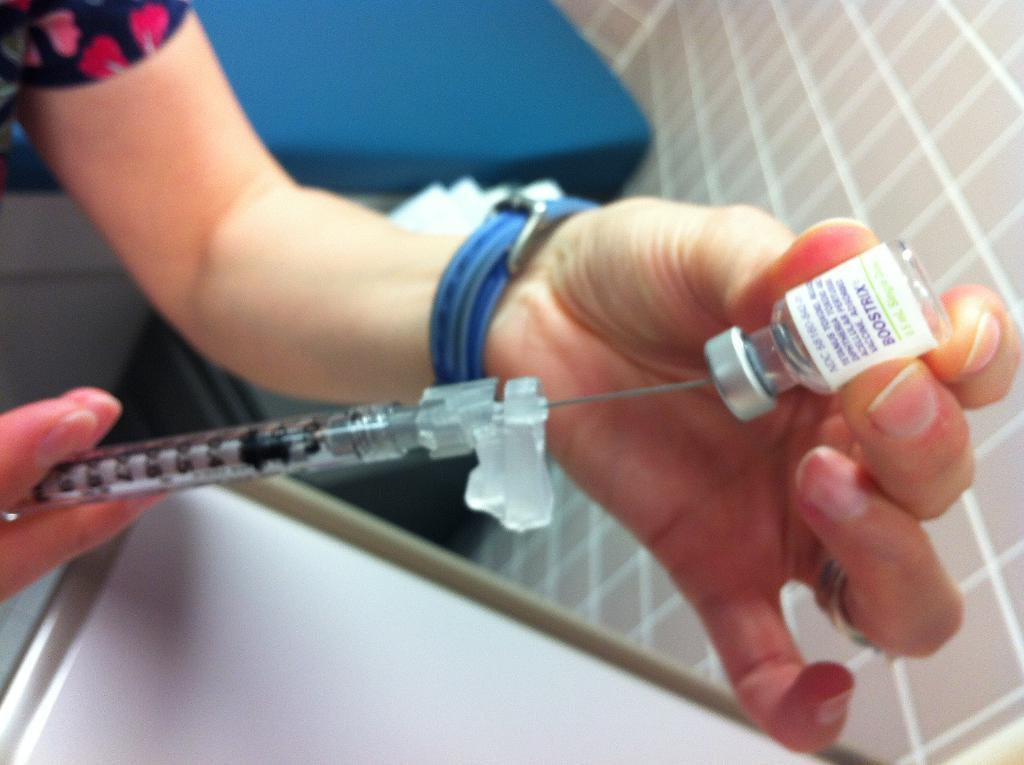What is the main subject of the image? There is a person in the image. What is the person holding in their hands? The person is holding a syringe and a bottle. Can you describe the background of the image? There are objects in the background of the image. What type of advice is the rat giving to the person in the image? There is no rat present in the image, so it is not possible to determine what advice might be given. 